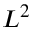<formula> <loc_0><loc_0><loc_500><loc_500>L ^ { 2 }</formula> 